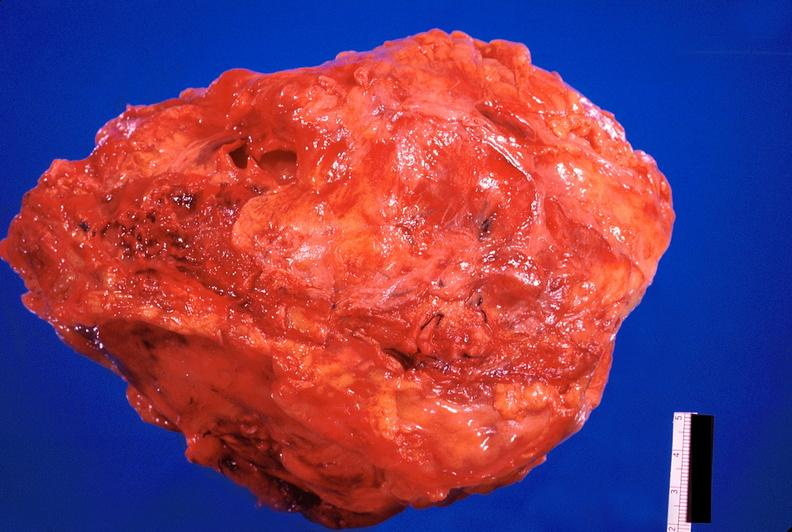what does this image show?
Answer the question using a single word or phrase. Pericarditis 